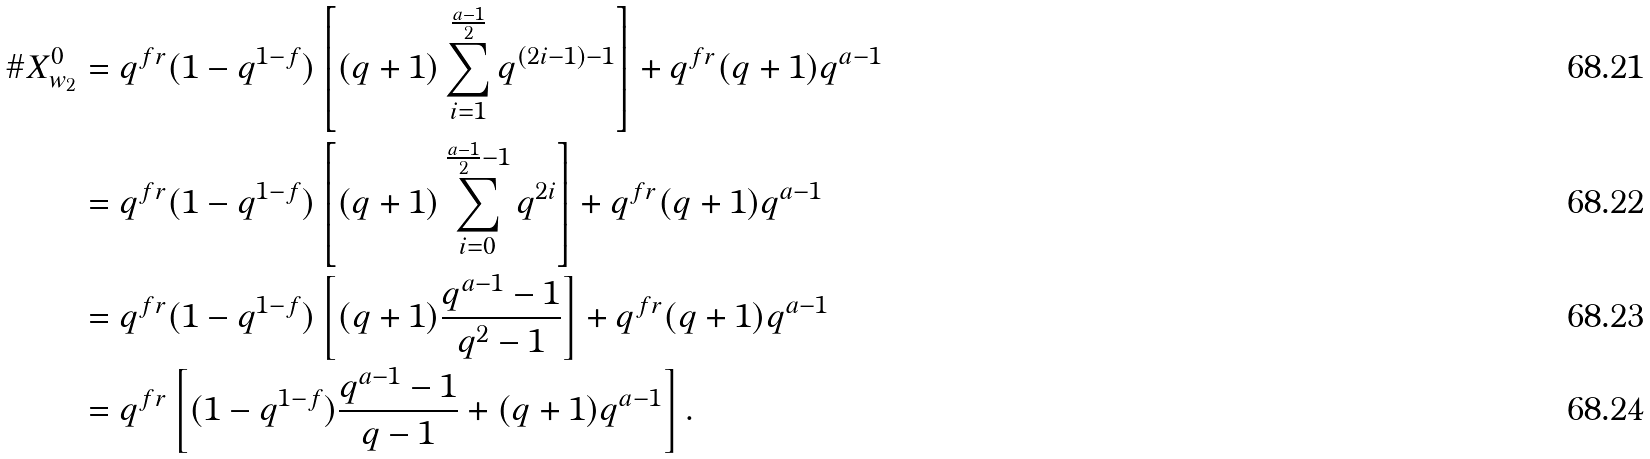<formula> <loc_0><loc_0><loc_500><loc_500>\# X ^ { 0 } _ { w _ { 2 } } & = q ^ { f r } ( 1 - q ^ { 1 - f } ) \left [ ( q + 1 ) \sum _ { i = 1 } ^ { \frac { a - 1 } { 2 } } q ^ { ( 2 i - 1 ) - 1 } \right ] + q ^ { f r } ( q + 1 ) q ^ { a - 1 } \\ & = q ^ { f r } ( 1 - q ^ { 1 - f } ) \left [ ( q + 1 ) \sum _ { i = 0 } ^ { \frac { a - 1 } { 2 } - 1 } q ^ { 2 i } \right ] + q ^ { f r } ( q + 1 ) q ^ { a - 1 } \\ & = q ^ { f r } ( 1 - q ^ { 1 - f } ) \left [ ( q + 1 ) \frac { q ^ { a - 1 } - 1 } { q ^ { 2 } - 1 } \right ] + q ^ { f r } ( q + 1 ) q ^ { a - 1 } \\ & = q ^ { f r } \left [ ( 1 - q ^ { 1 - f } ) \frac { q ^ { a - 1 } - 1 } { q - 1 } + ( q + 1 ) q ^ { a - 1 } \right ] .</formula> 